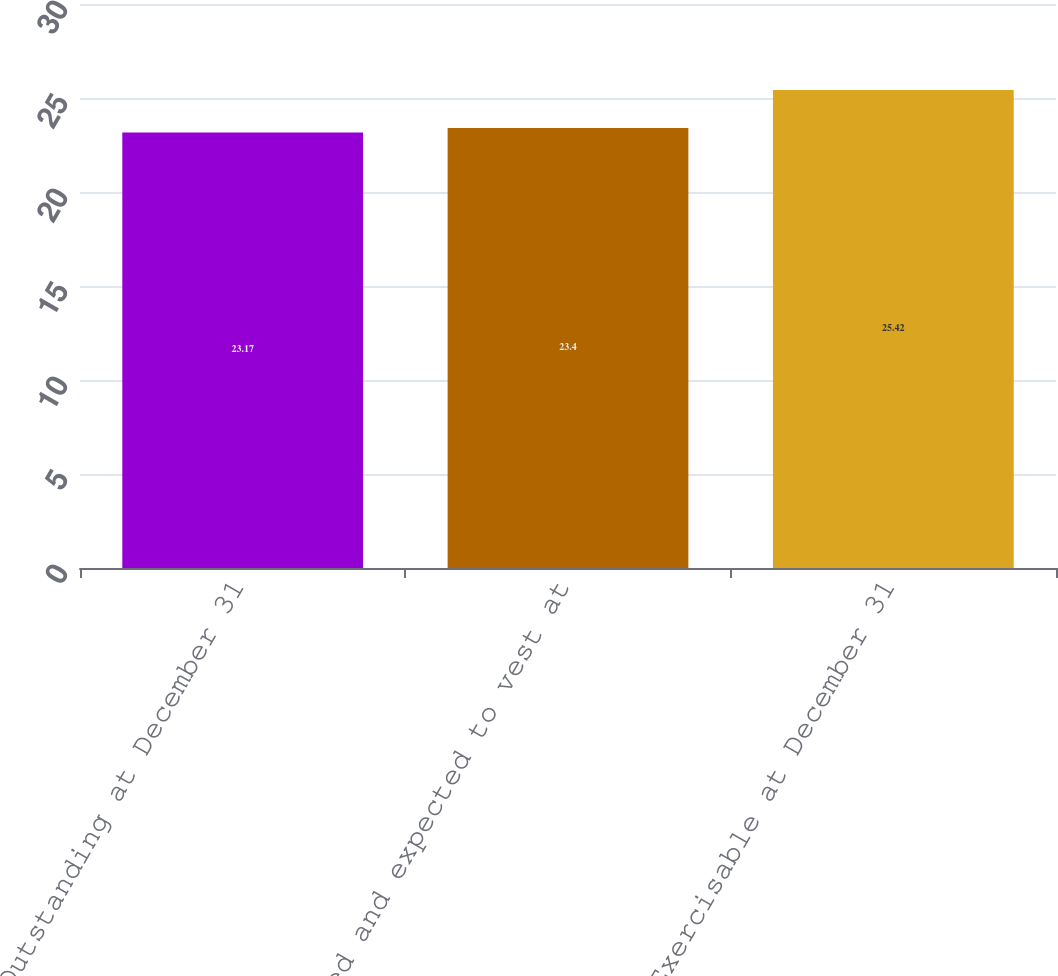<chart> <loc_0><loc_0><loc_500><loc_500><bar_chart><fcel>Outstanding at December 31<fcel>Vested and expected to vest at<fcel>Exercisable at December 31<nl><fcel>23.17<fcel>23.4<fcel>25.42<nl></chart> 